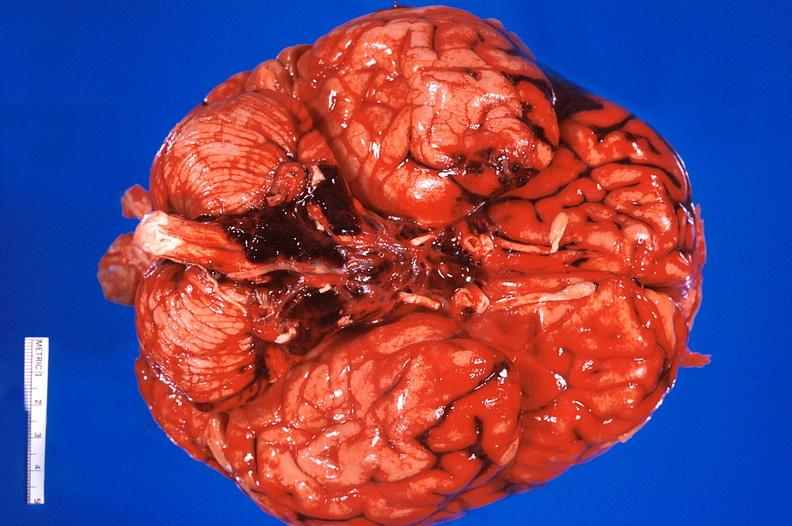does this image show brain?
Answer the question using a single word or phrase. Yes 